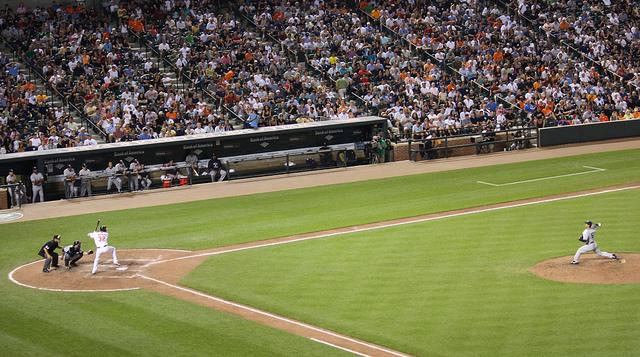The man wearing what color of shirt is responsible for rendering decisions on judgment calls?

Choices:
A) red
B) white
C) blue
D) black black 